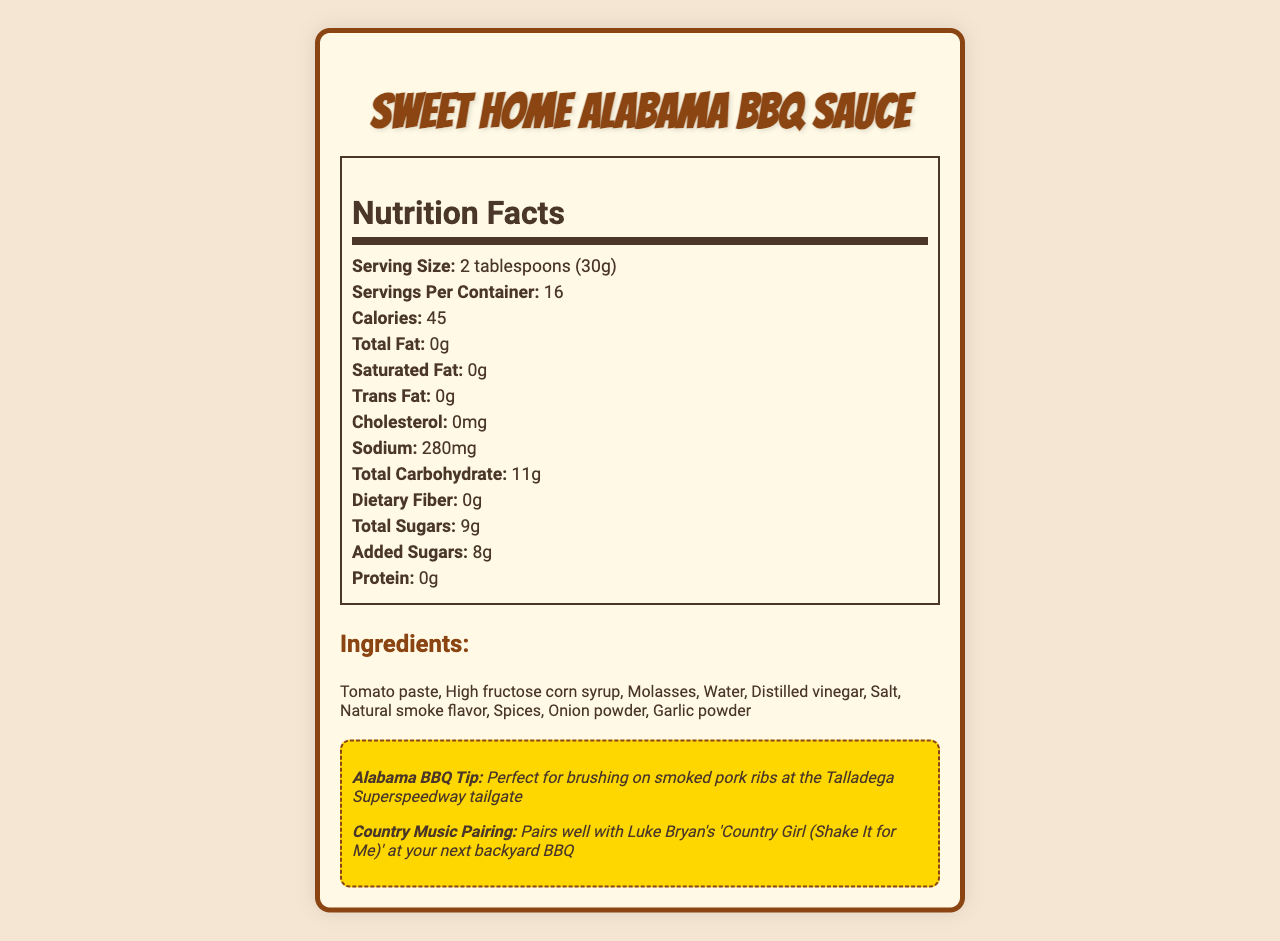What is the serving size of Sweet Home Alabama BBQ Sauce? The serving size is stated directly in the nutrition facts section of the document.
Answer: 2 tablespoons (30g) How many servings are in one container of Sweet Home Alabama BBQ Sauce? The document indicates that there are 16 servings per container.
Answer: 16 What is the sodium content per serving? The sodium content per serving is listed in the nutrition facts section mentioning "Sodium: 280mg".
Answer: 280mg How many grams of total carbohydrates are there per serving? The total carbohydrates per serving are specified as 11g in the nutrition facts.
Answer: 11g List three main ingredients in the BBQ sauce. These ingredients are the first three listed in the ingredients section of the document.
Answer: Tomato paste, High fructose corn syrup, Molasses What is the product name of the BBQ sauce? A. Southern Style BBQ Sauce B. Sweet Home Alabama BBQ Sauce C. Dixie Delight BBQ Sauce The product name "Sweet Home Alabama BBQ Sauce" is clearly stated at the top of the document.
Answer: B How many calories are in each serving? A. 40 B. 45 C. 50 D. 35 The calories per serving are indicated as 45 in the nutrition facts section.
Answer: B Which of the following is a dietary component listed as 0g? A. Dietary Fiber B. Total Sugars C. Trans Fat D. Protein The document lists "Trans Fat: 0g" in the nutrition facts.
Answer: C Does the Sweet Home Alabama BBQ Sauce contain any allergens? The document states that the sauce contains no allergens.
Answer: No Summarize the main idea of the document. The document centers on presenting comprehensive nutritional information about the BBQ sauce product while also adding local cultural elements related to Alabama.
Answer: The document provides the nutritional information, ingredients, and storage instructions for Sweet Home Alabama BBQ Sauce. It highlights key nutritional facts, such as calories, sodium, and carbohydrates, and also includes fun facts about Alabama BBQ and a country music pairing recommendation. What percentage of the daily recommended sodium intake is in one serving? The document does not provide the daily value percentage for sodium intake, only the amount in milligrams.
Answer: Not enough information 